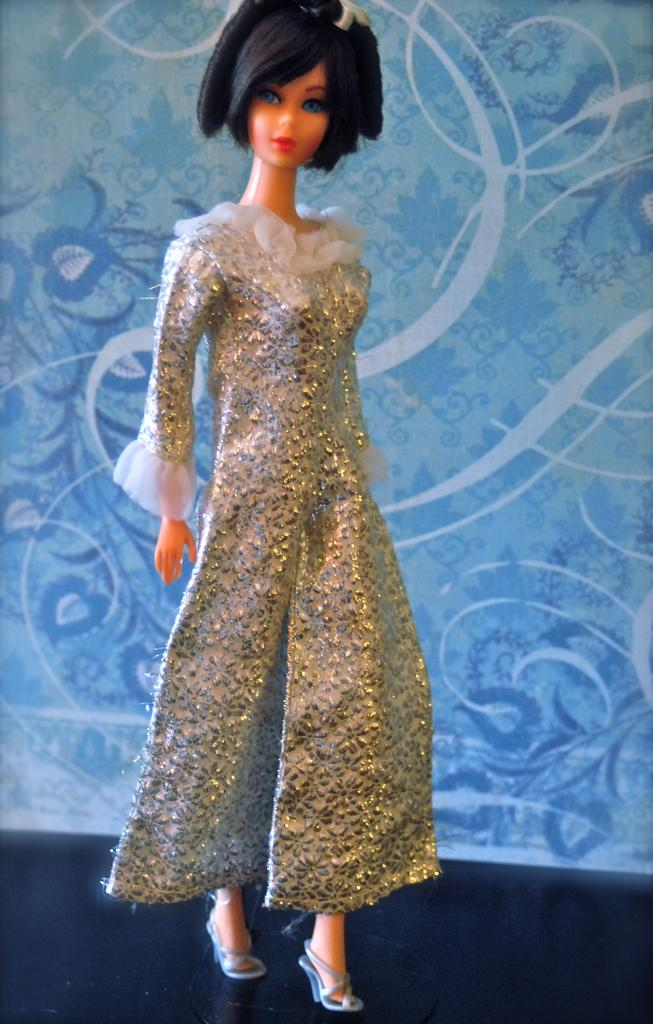What is the main subject of the image? There is a Barbie doll in the image. What can be observed about the Barbie doll's appearance? The Barbie doll has clothes on it. Can you describe the background of the image? There is a blue-colored wall with a design in the background of the image. What type of cake is being served to the group in the image? There is no cake or group present in the image; it features a Barbie doll with clothes on and a blue-colored wall with a design in the background. How is the string used in the image? There is no string present in the image. 